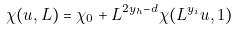<formula> <loc_0><loc_0><loc_500><loc_500>\chi ( u , L ) = \chi _ { 0 } + L ^ { 2 y _ { h } - d } \chi ( L ^ { y _ { i } } u , 1 )</formula> 